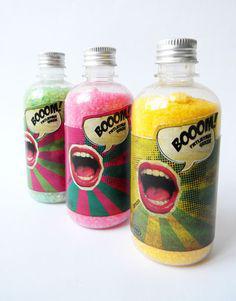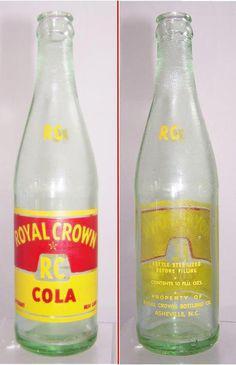The first image is the image on the left, the second image is the image on the right. For the images shown, is this caption "All bottles have labels on them, and no bottles are in boxes." true? Answer yes or no. Yes. The first image is the image on the left, the second image is the image on the right. For the images shown, is this caption "There are at least 3 green soda bottles within the rows of bottles." true? Answer yes or no. No. 